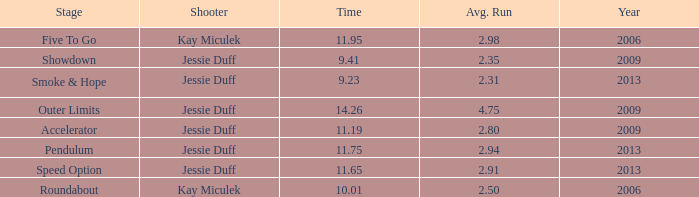26? 0.0. 